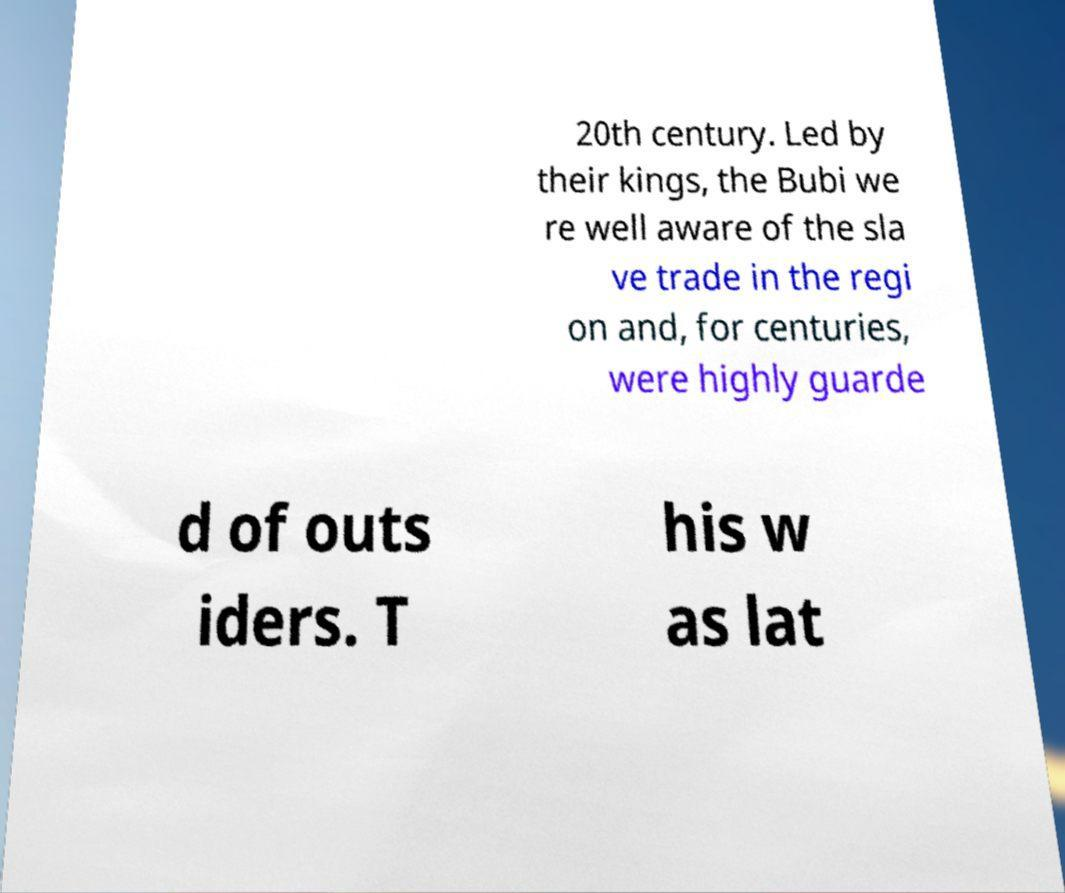Please identify and transcribe the text found in this image. 20th century. Led by their kings, the Bubi we re well aware of the sla ve trade in the regi on and, for centuries, were highly guarde d of outs iders. T his w as lat 